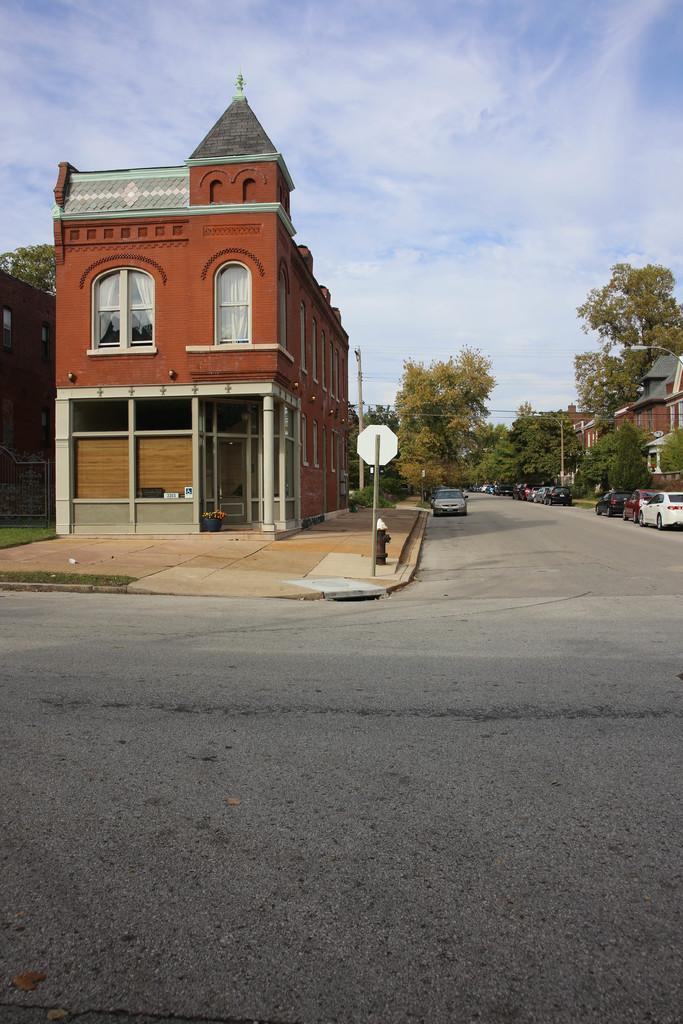In one or two sentences, can you explain what this image depicts? In the picture I can see the road, vehicles parked on the side of the road, I can see trees on the right side of the image, I can see buildings, fire hydrant, board, current poles, wires on the left side of the image and the blue color sky with clouds in the background. 